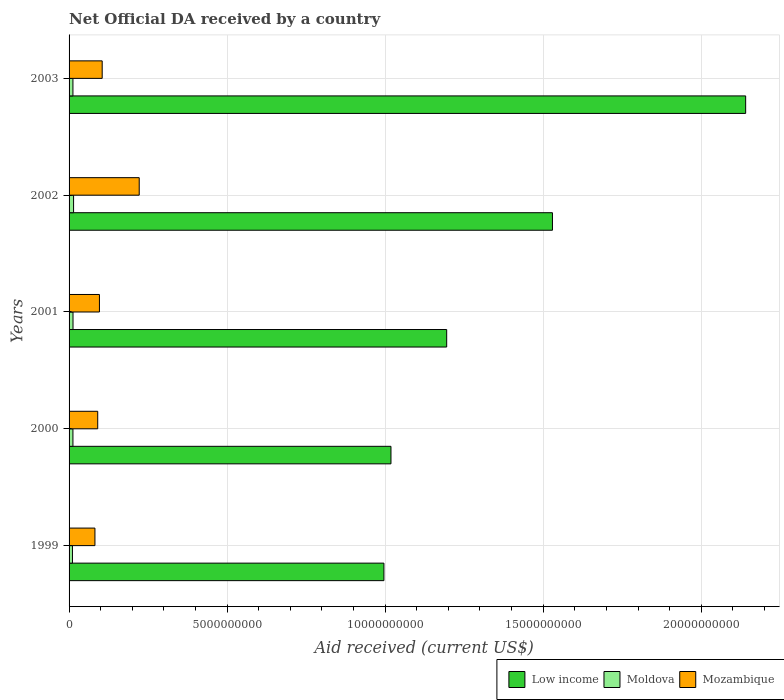How many different coloured bars are there?
Provide a succinct answer. 3. How many groups of bars are there?
Offer a very short reply. 5. Are the number of bars per tick equal to the number of legend labels?
Your response must be concise. Yes. Are the number of bars on each tick of the Y-axis equal?
Your answer should be very brief. Yes. How many bars are there on the 1st tick from the bottom?
Your answer should be compact. 3. What is the label of the 3rd group of bars from the top?
Make the answer very short. 2001. In how many cases, is the number of bars for a given year not equal to the number of legend labels?
Give a very brief answer. 0. What is the net official development assistance aid received in Low income in 2003?
Offer a very short reply. 2.14e+1. Across all years, what is the maximum net official development assistance aid received in Moldova?
Provide a succinct answer. 1.43e+08. Across all years, what is the minimum net official development assistance aid received in Low income?
Offer a very short reply. 9.96e+09. In which year was the net official development assistance aid received in Mozambique maximum?
Offer a terse response. 2002. What is the total net official development assistance aid received in Moldova in the graph?
Offer a terse response. 6.19e+08. What is the difference between the net official development assistance aid received in Mozambique in 2002 and that in 2003?
Your response must be concise. 1.17e+09. What is the difference between the net official development assistance aid received in Mozambique in 2001 and the net official development assistance aid received in Moldova in 2003?
Offer a very short reply. 8.38e+08. What is the average net official development assistance aid received in Mozambique per year?
Offer a terse response. 1.19e+09. In the year 1999, what is the difference between the net official development assistance aid received in Moldova and net official development assistance aid received in Low income?
Provide a short and direct response. -9.85e+09. In how many years, is the net official development assistance aid received in Low income greater than 18000000000 US$?
Provide a succinct answer. 1. What is the ratio of the net official development assistance aid received in Moldova in 1999 to that in 2003?
Your answer should be compact. 0.88. Is the net official development assistance aid received in Moldova in 1999 less than that in 2003?
Your answer should be very brief. Yes. Is the difference between the net official development assistance aid received in Moldova in 2000 and 2003 greater than the difference between the net official development assistance aid received in Low income in 2000 and 2003?
Your answer should be compact. Yes. What is the difference between the highest and the second highest net official development assistance aid received in Low income?
Your answer should be very brief. 6.11e+09. What is the difference between the highest and the lowest net official development assistance aid received in Moldova?
Ensure brevity in your answer.  3.55e+07. Is the sum of the net official development assistance aid received in Moldova in 1999 and 2000 greater than the maximum net official development assistance aid received in Low income across all years?
Provide a short and direct response. No. What does the 2nd bar from the top in 2002 represents?
Provide a succinct answer. Moldova. What does the 3rd bar from the bottom in 2000 represents?
Your response must be concise. Mozambique. Is it the case that in every year, the sum of the net official development assistance aid received in Low income and net official development assistance aid received in Moldova is greater than the net official development assistance aid received in Mozambique?
Your answer should be compact. Yes. How many bars are there?
Give a very brief answer. 15. What is the difference between two consecutive major ticks on the X-axis?
Give a very brief answer. 5.00e+09. Are the values on the major ticks of X-axis written in scientific E-notation?
Your answer should be very brief. No. Does the graph contain any zero values?
Keep it short and to the point. No. Does the graph contain grids?
Offer a terse response. Yes. Where does the legend appear in the graph?
Keep it short and to the point. Bottom right. How many legend labels are there?
Your answer should be compact. 3. How are the legend labels stacked?
Provide a succinct answer. Horizontal. What is the title of the graph?
Your response must be concise. Net Official DA received by a country. Does "Japan" appear as one of the legend labels in the graph?
Your answer should be compact. No. What is the label or title of the X-axis?
Provide a succinct answer. Aid received (current US$). What is the label or title of the Y-axis?
Your answer should be very brief. Years. What is the Aid received (current US$) in Low income in 1999?
Keep it short and to the point. 9.96e+09. What is the Aid received (current US$) of Moldova in 1999?
Keep it short and to the point. 1.07e+08. What is the Aid received (current US$) in Mozambique in 1999?
Your answer should be compact. 8.19e+08. What is the Aid received (current US$) of Low income in 2000?
Ensure brevity in your answer.  1.02e+1. What is the Aid received (current US$) in Moldova in 2000?
Ensure brevity in your answer.  1.22e+08. What is the Aid received (current US$) of Mozambique in 2000?
Your answer should be compact. 9.06e+08. What is the Aid received (current US$) of Low income in 2001?
Ensure brevity in your answer.  1.19e+1. What is the Aid received (current US$) in Moldova in 2001?
Make the answer very short. 1.25e+08. What is the Aid received (current US$) in Mozambique in 2001?
Keep it short and to the point. 9.61e+08. What is the Aid received (current US$) of Low income in 2002?
Ensure brevity in your answer.  1.53e+1. What is the Aid received (current US$) of Moldova in 2002?
Offer a terse response. 1.43e+08. What is the Aid received (current US$) of Mozambique in 2002?
Ensure brevity in your answer.  2.22e+09. What is the Aid received (current US$) in Low income in 2003?
Your answer should be compact. 2.14e+1. What is the Aid received (current US$) in Moldova in 2003?
Keep it short and to the point. 1.22e+08. What is the Aid received (current US$) of Mozambique in 2003?
Your response must be concise. 1.05e+09. Across all years, what is the maximum Aid received (current US$) of Low income?
Your answer should be compact. 2.14e+1. Across all years, what is the maximum Aid received (current US$) in Moldova?
Provide a succinct answer. 1.43e+08. Across all years, what is the maximum Aid received (current US$) of Mozambique?
Give a very brief answer. 2.22e+09. Across all years, what is the minimum Aid received (current US$) in Low income?
Your answer should be compact. 9.96e+09. Across all years, what is the minimum Aid received (current US$) of Moldova?
Provide a short and direct response. 1.07e+08. Across all years, what is the minimum Aid received (current US$) in Mozambique?
Offer a very short reply. 8.19e+08. What is the total Aid received (current US$) in Low income in the graph?
Your answer should be compact. 6.88e+1. What is the total Aid received (current US$) in Moldova in the graph?
Make the answer very short. 6.19e+08. What is the total Aid received (current US$) in Mozambique in the graph?
Your response must be concise. 5.95e+09. What is the difference between the Aid received (current US$) in Low income in 1999 and that in 2000?
Offer a terse response. -2.23e+08. What is the difference between the Aid received (current US$) in Moldova in 1999 and that in 2000?
Offer a very short reply. -1.54e+07. What is the difference between the Aid received (current US$) of Mozambique in 1999 and that in 2000?
Ensure brevity in your answer.  -8.77e+07. What is the difference between the Aid received (current US$) of Low income in 1999 and that in 2001?
Give a very brief answer. -1.99e+09. What is the difference between the Aid received (current US$) in Moldova in 1999 and that in 2001?
Make the answer very short. -1.76e+07. What is the difference between the Aid received (current US$) of Mozambique in 1999 and that in 2001?
Your answer should be compact. -1.42e+08. What is the difference between the Aid received (current US$) of Low income in 1999 and that in 2002?
Offer a terse response. -5.33e+09. What is the difference between the Aid received (current US$) in Moldova in 1999 and that in 2002?
Offer a terse response. -3.55e+07. What is the difference between the Aid received (current US$) of Mozambique in 1999 and that in 2002?
Your answer should be very brief. -1.40e+09. What is the difference between the Aid received (current US$) of Low income in 1999 and that in 2003?
Provide a succinct answer. -1.14e+1. What is the difference between the Aid received (current US$) in Moldova in 1999 and that in 2003?
Provide a succinct answer. -1.52e+07. What is the difference between the Aid received (current US$) in Mozambique in 1999 and that in 2003?
Make the answer very short. -2.29e+08. What is the difference between the Aid received (current US$) in Low income in 2000 and that in 2001?
Offer a very short reply. -1.76e+09. What is the difference between the Aid received (current US$) of Moldova in 2000 and that in 2001?
Provide a succinct answer. -2.26e+06. What is the difference between the Aid received (current US$) of Mozambique in 2000 and that in 2001?
Make the answer very short. -5.45e+07. What is the difference between the Aid received (current US$) in Low income in 2000 and that in 2002?
Your answer should be compact. -5.11e+09. What is the difference between the Aid received (current US$) in Moldova in 2000 and that in 2002?
Make the answer very short. -2.01e+07. What is the difference between the Aid received (current US$) of Mozambique in 2000 and that in 2002?
Your answer should be very brief. -1.31e+09. What is the difference between the Aid received (current US$) of Low income in 2000 and that in 2003?
Offer a terse response. -1.12e+1. What is the difference between the Aid received (current US$) of Mozambique in 2000 and that in 2003?
Ensure brevity in your answer.  -1.42e+08. What is the difference between the Aid received (current US$) of Low income in 2001 and that in 2002?
Your response must be concise. -3.35e+09. What is the difference between the Aid received (current US$) of Moldova in 2001 and that in 2002?
Your answer should be very brief. -1.78e+07. What is the difference between the Aid received (current US$) in Mozambique in 2001 and that in 2002?
Give a very brief answer. -1.26e+09. What is the difference between the Aid received (current US$) in Low income in 2001 and that in 2003?
Ensure brevity in your answer.  -9.46e+09. What is the difference between the Aid received (current US$) of Moldova in 2001 and that in 2003?
Offer a terse response. 2.46e+06. What is the difference between the Aid received (current US$) of Mozambique in 2001 and that in 2003?
Your answer should be compact. -8.72e+07. What is the difference between the Aid received (current US$) of Low income in 2002 and that in 2003?
Provide a short and direct response. -6.11e+09. What is the difference between the Aid received (current US$) of Moldova in 2002 and that in 2003?
Your answer should be compact. 2.03e+07. What is the difference between the Aid received (current US$) in Mozambique in 2002 and that in 2003?
Your response must be concise. 1.17e+09. What is the difference between the Aid received (current US$) of Low income in 1999 and the Aid received (current US$) of Moldova in 2000?
Your answer should be very brief. 9.84e+09. What is the difference between the Aid received (current US$) in Low income in 1999 and the Aid received (current US$) in Mozambique in 2000?
Provide a succinct answer. 9.05e+09. What is the difference between the Aid received (current US$) of Moldova in 1999 and the Aid received (current US$) of Mozambique in 2000?
Provide a short and direct response. -7.99e+08. What is the difference between the Aid received (current US$) in Low income in 1999 and the Aid received (current US$) in Moldova in 2001?
Provide a short and direct response. 9.84e+09. What is the difference between the Aid received (current US$) in Low income in 1999 and the Aid received (current US$) in Mozambique in 2001?
Your answer should be compact. 9.00e+09. What is the difference between the Aid received (current US$) in Moldova in 1999 and the Aid received (current US$) in Mozambique in 2001?
Ensure brevity in your answer.  -8.54e+08. What is the difference between the Aid received (current US$) of Low income in 1999 and the Aid received (current US$) of Moldova in 2002?
Your answer should be compact. 9.82e+09. What is the difference between the Aid received (current US$) of Low income in 1999 and the Aid received (current US$) of Mozambique in 2002?
Your answer should be compact. 7.74e+09. What is the difference between the Aid received (current US$) of Moldova in 1999 and the Aid received (current US$) of Mozambique in 2002?
Make the answer very short. -2.11e+09. What is the difference between the Aid received (current US$) in Low income in 1999 and the Aid received (current US$) in Moldova in 2003?
Provide a short and direct response. 9.84e+09. What is the difference between the Aid received (current US$) in Low income in 1999 and the Aid received (current US$) in Mozambique in 2003?
Your answer should be very brief. 8.91e+09. What is the difference between the Aid received (current US$) in Moldova in 1999 and the Aid received (current US$) in Mozambique in 2003?
Offer a very short reply. -9.41e+08. What is the difference between the Aid received (current US$) of Low income in 2000 and the Aid received (current US$) of Moldova in 2001?
Your answer should be compact. 1.01e+1. What is the difference between the Aid received (current US$) in Low income in 2000 and the Aid received (current US$) in Mozambique in 2001?
Provide a succinct answer. 9.22e+09. What is the difference between the Aid received (current US$) of Moldova in 2000 and the Aid received (current US$) of Mozambique in 2001?
Keep it short and to the point. -8.38e+08. What is the difference between the Aid received (current US$) in Low income in 2000 and the Aid received (current US$) in Moldova in 2002?
Your answer should be compact. 1.00e+1. What is the difference between the Aid received (current US$) in Low income in 2000 and the Aid received (current US$) in Mozambique in 2002?
Your answer should be compact. 7.96e+09. What is the difference between the Aid received (current US$) of Moldova in 2000 and the Aid received (current US$) of Mozambique in 2002?
Offer a terse response. -2.10e+09. What is the difference between the Aid received (current US$) in Low income in 2000 and the Aid received (current US$) in Moldova in 2003?
Provide a short and direct response. 1.01e+1. What is the difference between the Aid received (current US$) in Low income in 2000 and the Aid received (current US$) in Mozambique in 2003?
Give a very brief answer. 9.14e+09. What is the difference between the Aid received (current US$) of Moldova in 2000 and the Aid received (current US$) of Mozambique in 2003?
Provide a short and direct response. -9.25e+08. What is the difference between the Aid received (current US$) in Low income in 2001 and the Aid received (current US$) in Moldova in 2002?
Your response must be concise. 1.18e+1. What is the difference between the Aid received (current US$) in Low income in 2001 and the Aid received (current US$) in Mozambique in 2002?
Ensure brevity in your answer.  9.73e+09. What is the difference between the Aid received (current US$) of Moldova in 2001 and the Aid received (current US$) of Mozambique in 2002?
Your answer should be compact. -2.09e+09. What is the difference between the Aid received (current US$) in Low income in 2001 and the Aid received (current US$) in Moldova in 2003?
Your answer should be compact. 1.18e+1. What is the difference between the Aid received (current US$) of Low income in 2001 and the Aid received (current US$) of Mozambique in 2003?
Give a very brief answer. 1.09e+1. What is the difference between the Aid received (current US$) of Moldova in 2001 and the Aid received (current US$) of Mozambique in 2003?
Provide a short and direct response. -9.23e+08. What is the difference between the Aid received (current US$) in Low income in 2002 and the Aid received (current US$) in Moldova in 2003?
Your response must be concise. 1.52e+1. What is the difference between the Aid received (current US$) in Low income in 2002 and the Aid received (current US$) in Mozambique in 2003?
Provide a succinct answer. 1.42e+1. What is the difference between the Aid received (current US$) of Moldova in 2002 and the Aid received (current US$) of Mozambique in 2003?
Your response must be concise. -9.05e+08. What is the average Aid received (current US$) of Low income per year?
Offer a terse response. 1.38e+1. What is the average Aid received (current US$) of Moldova per year?
Provide a succinct answer. 1.24e+08. What is the average Aid received (current US$) of Mozambique per year?
Give a very brief answer. 1.19e+09. In the year 1999, what is the difference between the Aid received (current US$) of Low income and Aid received (current US$) of Moldova?
Keep it short and to the point. 9.85e+09. In the year 1999, what is the difference between the Aid received (current US$) in Low income and Aid received (current US$) in Mozambique?
Your answer should be very brief. 9.14e+09. In the year 1999, what is the difference between the Aid received (current US$) in Moldova and Aid received (current US$) in Mozambique?
Give a very brief answer. -7.11e+08. In the year 2000, what is the difference between the Aid received (current US$) of Low income and Aid received (current US$) of Moldova?
Keep it short and to the point. 1.01e+1. In the year 2000, what is the difference between the Aid received (current US$) in Low income and Aid received (current US$) in Mozambique?
Make the answer very short. 9.28e+09. In the year 2000, what is the difference between the Aid received (current US$) of Moldova and Aid received (current US$) of Mozambique?
Make the answer very short. -7.84e+08. In the year 2001, what is the difference between the Aid received (current US$) of Low income and Aid received (current US$) of Moldova?
Your answer should be very brief. 1.18e+1. In the year 2001, what is the difference between the Aid received (current US$) in Low income and Aid received (current US$) in Mozambique?
Ensure brevity in your answer.  1.10e+1. In the year 2001, what is the difference between the Aid received (current US$) in Moldova and Aid received (current US$) in Mozambique?
Keep it short and to the point. -8.36e+08. In the year 2002, what is the difference between the Aid received (current US$) of Low income and Aid received (current US$) of Moldova?
Your answer should be very brief. 1.52e+1. In the year 2002, what is the difference between the Aid received (current US$) of Low income and Aid received (current US$) of Mozambique?
Give a very brief answer. 1.31e+1. In the year 2002, what is the difference between the Aid received (current US$) of Moldova and Aid received (current US$) of Mozambique?
Offer a terse response. -2.08e+09. In the year 2003, what is the difference between the Aid received (current US$) of Low income and Aid received (current US$) of Moldova?
Keep it short and to the point. 2.13e+1. In the year 2003, what is the difference between the Aid received (current US$) in Low income and Aid received (current US$) in Mozambique?
Give a very brief answer. 2.04e+1. In the year 2003, what is the difference between the Aid received (current US$) in Moldova and Aid received (current US$) in Mozambique?
Make the answer very short. -9.26e+08. What is the ratio of the Aid received (current US$) of Low income in 1999 to that in 2000?
Your response must be concise. 0.98. What is the ratio of the Aid received (current US$) in Moldova in 1999 to that in 2000?
Make the answer very short. 0.87. What is the ratio of the Aid received (current US$) of Mozambique in 1999 to that in 2000?
Provide a short and direct response. 0.9. What is the ratio of the Aid received (current US$) in Low income in 1999 to that in 2001?
Your answer should be compact. 0.83. What is the ratio of the Aid received (current US$) in Moldova in 1999 to that in 2001?
Your answer should be very brief. 0.86. What is the ratio of the Aid received (current US$) of Mozambique in 1999 to that in 2001?
Offer a terse response. 0.85. What is the ratio of the Aid received (current US$) of Low income in 1999 to that in 2002?
Your response must be concise. 0.65. What is the ratio of the Aid received (current US$) in Moldova in 1999 to that in 2002?
Give a very brief answer. 0.75. What is the ratio of the Aid received (current US$) of Mozambique in 1999 to that in 2002?
Your answer should be very brief. 0.37. What is the ratio of the Aid received (current US$) of Low income in 1999 to that in 2003?
Offer a terse response. 0.47. What is the ratio of the Aid received (current US$) of Moldova in 1999 to that in 2003?
Your answer should be compact. 0.88. What is the ratio of the Aid received (current US$) of Mozambique in 1999 to that in 2003?
Make the answer very short. 0.78. What is the ratio of the Aid received (current US$) in Low income in 2000 to that in 2001?
Offer a terse response. 0.85. What is the ratio of the Aid received (current US$) of Moldova in 2000 to that in 2001?
Offer a terse response. 0.98. What is the ratio of the Aid received (current US$) in Mozambique in 2000 to that in 2001?
Make the answer very short. 0.94. What is the ratio of the Aid received (current US$) in Low income in 2000 to that in 2002?
Offer a very short reply. 0.67. What is the ratio of the Aid received (current US$) of Moldova in 2000 to that in 2002?
Provide a short and direct response. 0.86. What is the ratio of the Aid received (current US$) in Mozambique in 2000 to that in 2002?
Provide a short and direct response. 0.41. What is the ratio of the Aid received (current US$) of Low income in 2000 to that in 2003?
Provide a succinct answer. 0.48. What is the ratio of the Aid received (current US$) of Moldova in 2000 to that in 2003?
Offer a terse response. 1. What is the ratio of the Aid received (current US$) of Mozambique in 2000 to that in 2003?
Give a very brief answer. 0.86. What is the ratio of the Aid received (current US$) of Low income in 2001 to that in 2002?
Make the answer very short. 0.78. What is the ratio of the Aid received (current US$) in Moldova in 2001 to that in 2002?
Ensure brevity in your answer.  0.87. What is the ratio of the Aid received (current US$) in Mozambique in 2001 to that in 2002?
Provide a succinct answer. 0.43. What is the ratio of the Aid received (current US$) of Low income in 2001 to that in 2003?
Offer a terse response. 0.56. What is the ratio of the Aid received (current US$) in Moldova in 2001 to that in 2003?
Offer a terse response. 1.02. What is the ratio of the Aid received (current US$) of Low income in 2002 to that in 2003?
Your answer should be very brief. 0.71. What is the ratio of the Aid received (current US$) of Moldova in 2002 to that in 2003?
Your response must be concise. 1.17. What is the ratio of the Aid received (current US$) in Mozambique in 2002 to that in 2003?
Provide a succinct answer. 2.12. What is the difference between the highest and the second highest Aid received (current US$) of Low income?
Your answer should be very brief. 6.11e+09. What is the difference between the highest and the second highest Aid received (current US$) in Moldova?
Provide a succinct answer. 1.78e+07. What is the difference between the highest and the second highest Aid received (current US$) in Mozambique?
Offer a terse response. 1.17e+09. What is the difference between the highest and the lowest Aid received (current US$) of Low income?
Your answer should be compact. 1.14e+1. What is the difference between the highest and the lowest Aid received (current US$) of Moldova?
Offer a very short reply. 3.55e+07. What is the difference between the highest and the lowest Aid received (current US$) of Mozambique?
Keep it short and to the point. 1.40e+09. 